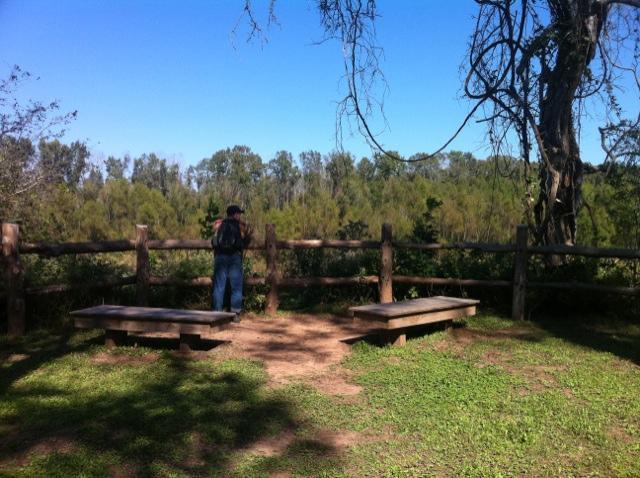How many benches are there?
Give a very brief answer. 2. How many eyelashes does the cat have?
Give a very brief answer. 0. 